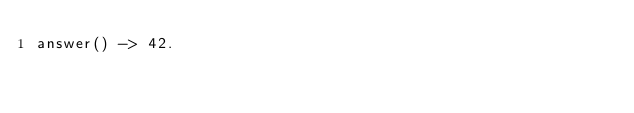<code> <loc_0><loc_0><loc_500><loc_500><_Erlang_>answer() -> 42.
</code> 